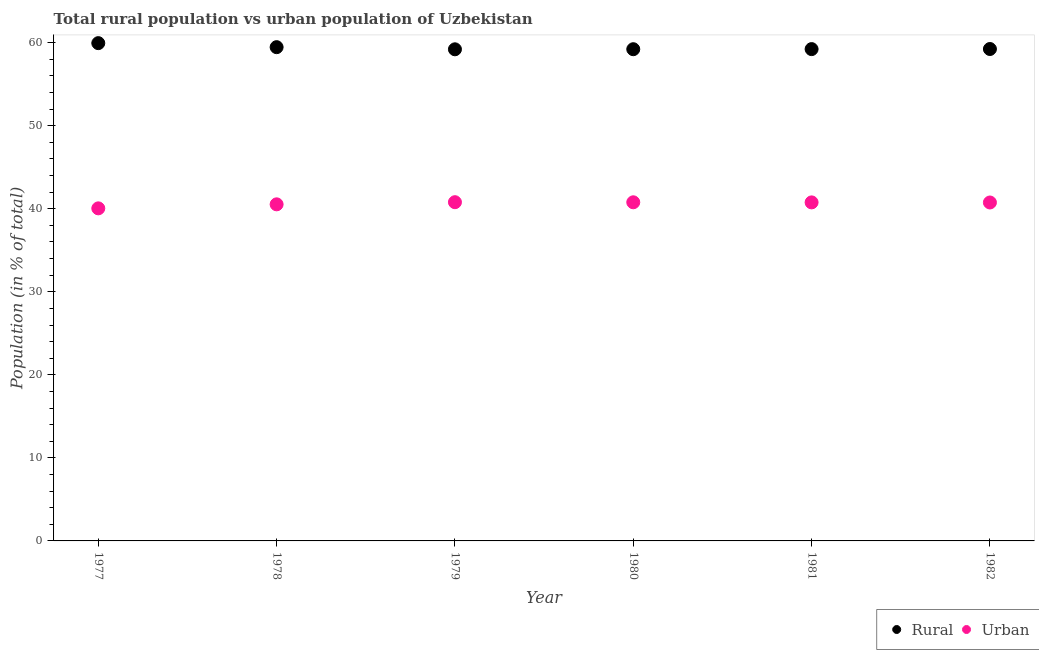What is the urban population in 1979?
Provide a short and direct response. 40.79. Across all years, what is the maximum urban population?
Your response must be concise. 40.79. Across all years, what is the minimum urban population?
Ensure brevity in your answer.  40.05. In which year was the urban population maximum?
Ensure brevity in your answer.  1979. What is the total urban population in the graph?
Keep it short and to the point. 243.69. What is the difference between the urban population in 1977 and that in 1981?
Offer a very short reply. -0.72. What is the difference between the urban population in 1982 and the rural population in 1979?
Your answer should be compact. -18.45. What is the average urban population per year?
Provide a short and direct response. 40.62. In the year 1980, what is the difference between the rural population and urban population?
Give a very brief answer. 18.44. What is the ratio of the urban population in 1979 to that in 1982?
Ensure brevity in your answer.  1. Is the rural population in 1979 less than that in 1981?
Provide a short and direct response. Yes. What is the difference between the highest and the second highest rural population?
Make the answer very short. 0.48. What is the difference between the highest and the lowest rural population?
Make the answer very short. 0.74. Is the sum of the rural population in 1979 and 1981 greater than the maximum urban population across all years?
Offer a very short reply. Yes. Does the urban population monotonically increase over the years?
Offer a terse response. No. Is the urban population strictly less than the rural population over the years?
Ensure brevity in your answer.  Yes. How many dotlines are there?
Your answer should be very brief. 2. How many years are there in the graph?
Offer a very short reply. 6. Are the values on the major ticks of Y-axis written in scientific E-notation?
Offer a very short reply. No. Does the graph contain any zero values?
Provide a short and direct response. No. How are the legend labels stacked?
Ensure brevity in your answer.  Horizontal. What is the title of the graph?
Make the answer very short. Total rural population vs urban population of Uzbekistan. What is the label or title of the Y-axis?
Provide a succinct answer. Population (in % of total). What is the Population (in % of total) in Rural in 1977?
Your response must be concise. 59.95. What is the Population (in % of total) of Urban in 1977?
Your answer should be compact. 40.05. What is the Population (in % of total) of Rural in 1978?
Make the answer very short. 59.46. What is the Population (in % of total) of Urban in 1978?
Give a very brief answer. 40.54. What is the Population (in % of total) in Rural in 1979?
Keep it short and to the point. 59.21. What is the Population (in % of total) of Urban in 1979?
Your response must be concise. 40.79. What is the Population (in % of total) in Rural in 1980?
Make the answer very short. 59.22. What is the Population (in % of total) of Urban in 1980?
Offer a very short reply. 40.78. What is the Population (in % of total) in Rural in 1981?
Provide a short and direct response. 59.23. What is the Population (in % of total) in Urban in 1981?
Keep it short and to the point. 40.77. What is the Population (in % of total) in Rural in 1982?
Provide a short and direct response. 59.24. What is the Population (in % of total) of Urban in 1982?
Keep it short and to the point. 40.76. Across all years, what is the maximum Population (in % of total) in Rural?
Keep it short and to the point. 59.95. Across all years, what is the maximum Population (in % of total) in Urban?
Provide a succinct answer. 40.79. Across all years, what is the minimum Population (in % of total) of Rural?
Offer a very short reply. 59.21. Across all years, what is the minimum Population (in % of total) in Urban?
Make the answer very short. 40.05. What is the total Population (in % of total) of Rural in the graph?
Ensure brevity in your answer.  356.31. What is the total Population (in % of total) of Urban in the graph?
Provide a succinct answer. 243.69. What is the difference between the Population (in % of total) in Rural in 1977 and that in 1978?
Give a very brief answer. 0.48. What is the difference between the Population (in % of total) in Urban in 1977 and that in 1978?
Your answer should be very brief. -0.48. What is the difference between the Population (in % of total) in Rural in 1977 and that in 1979?
Provide a short and direct response. 0.74. What is the difference between the Population (in % of total) in Urban in 1977 and that in 1979?
Your response must be concise. -0.74. What is the difference between the Population (in % of total) in Rural in 1977 and that in 1980?
Make the answer very short. 0.73. What is the difference between the Population (in % of total) of Urban in 1977 and that in 1980?
Your answer should be very brief. -0.73. What is the difference between the Population (in % of total) in Rural in 1977 and that in 1981?
Give a very brief answer. 0.72. What is the difference between the Population (in % of total) of Urban in 1977 and that in 1981?
Ensure brevity in your answer.  -0.72. What is the difference between the Population (in % of total) of Rural in 1977 and that in 1982?
Your answer should be compact. 0.71. What is the difference between the Population (in % of total) of Urban in 1977 and that in 1982?
Provide a succinct answer. -0.71. What is the difference between the Population (in % of total) of Rural in 1978 and that in 1979?
Provide a short and direct response. 0.26. What is the difference between the Population (in % of total) in Urban in 1978 and that in 1979?
Offer a very short reply. -0.26. What is the difference between the Population (in % of total) of Rural in 1978 and that in 1980?
Ensure brevity in your answer.  0.25. What is the difference between the Population (in % of total) of Urban in 1978 and that in 1980?
Provide a succinct answer. -0.25. What is the difference between the Population (in % of total) of Rural in 1978 and that in 1981?
Provide a short and direct response. 0.23. What is the difference between the Population (in % of total) in Urban in 1978 and that in 1981?
Provide a succinct answer. -0.23. What is the difference between the Population (in % of total) in Rural in 1978 and that in 1982?
Your answer should be very brief. 0.22. What is the difference between the Population (in % of total) in Urban in 1978 and that in 1982?
Keep it short and to the point. -0.22. What is the difference between the Population (in % of total) in Rural in 1979 and that in 1980?
Make the answer very short. -0.01. What is the difference between the Population (in % of total) of Urban in 1979 and that in 1980?
Offer a terse response. 0.01. What is the difference between the Population (in % of total) of Rural in 1979 and that in 1981?
Make the answer very short. -0.02. What is the difference between the Population (in % of total) in Urban in 1979 and that in 1981?
Provide a succinct answer. 0.02. What is the difference between the Population (in % of total) of Rural in 1979 and that in 1982?
Provide a succinct answer. -0.04. What is the difference between the Population (in % of total) in Urban in 1979 and that in 1982?
Ensure brevity in your answer.  0.04. What is the difference between the Population (in % of total) in Rural in 1980 and that in 1981?
Offer a terse response. -0.01. What is the difference between the Population (in % of total) in Urban in 1980 and that in 1981?
Provide a succinct answer. 0.01. What is the difference between the Population (in % of total) of Rural in 1980 and that in 1982?
Your response must be concise. -0.02. What is the difference between the Population (in % of total) of Urban in 1980 and that in 1982?
Your answer should be compact. 0.02. What is the difference between the Population (in % of total) of Rural in 1981 and that in 1982?
Your answer should be compact. -0.01. What is the difference between the Population (in % of total) in Urban in 1981 and that in 1982?
Your answer should be compact. 0.01. What is the difference between the Population (in % of total) in Rural in 1977 and the Population (in % of total) in Urban in 1978?
Provide a short and direct response. 19.41. What is the difference between the Population (in % of total) of Rural in 1977 and the Population (in % of total) of Urban in 1979?
Provide a short and direct response. 19.16. What is the difference between the Population (in % of total) in Rural in 1977 and the Population (in % of total) in Urban in 1980?
Your response must be concise. 19.17. What is the difference between the Population (in % of total) in Rural in 1977 and the Population (in % of total) in Urban in 1981?
Your answer should be very brief. 19.18. What is the difference between the Population (in % of total) of Rural in 1977 and the Population (in % of total) of Urban in 1982?
Your answer should be very brief. 19.19. What is the difference between the Population (in % of total) in Rural in 1978 and the Population (in % of total) in Urban in 1979?
Your answer should be very brief. 18.67. What is the difference between the Population (in % of total) in Rural in 1978 and the Population (in % of total) in Urban in 1980?
Your answer should be compact. 18.68. What is the difference between the Population (in % of total) in Rural in 1978 and the Population (in % of total) in Urban in 1981?
Your answer should be very brief. 18.69. What is the difference between the Population (in % of total) in Rural in 1978 and the Population (in % of total) in Urban in 1982?
Ensure brevity in your answer.  18.71. What is the difference between the Population (in % of total) of Rural in 1979 and the Population (in % of total) of Urban in 1980?
Make the answer very short. 18.42. What is the difference between the Population (in % of total) in Rural in 1979 and the Population (in % of total) in Urban in 1981?
Ensure brevity in your answer.  18.44. What is the difference between the Population (in % of total) in Rural in 1979 and the Population (in % of total) in Urban in 1982?
Your answer should be very brief. 18.45. What is the difference between the Population (in % of total) in Rural in 1980 and the Population (in % of total) in Urban in 1981?
Offer a terse response. 18.45. What is the difference between the Population (in % of total) of Rural in 1980 and the Population (in % of total) of Urban in 1982?
Your response must be concise. 18.46. What is the difference between the Population (in % of total) of Rural in 1981 and the Population (in % of total) of Urban in 1982?
Your response must be concise. 18.47. What is the average Population (in % of total) in Rural per year?
Offer a terse response. 59.38. What is the average Population (in % of total) of Urban per year?
Your answer should be compact. 40.62. In the year 1977, what is the difference between the Population (in % of total) of Rural and Population (in % of total) of Urban?
Your answer should be compact. 19.9. In the year 1978, what is the difference between the Population (in % of total) of Rural and Population (in % of total) of Urban?
Your answer should be very brief. 18.93. In the year 1979, what is the difference between the Population (in % of total) in Rural and Population (in % of total) in Urban?
Give a very brief answer. 18.41. In the year 1980, what is the difference between the Population (in % of total) in Rural and Population (in % of total) in Urban?
Offer a very short reply. 18.44. In the year 1981, what is the difference between the Population (in % of total) in Rural and Population (in % of total) in Urban?
Your answer should be compact. 18.46. In the year 1982, what is the difference between the Population (in % of total) of Rural and Population (in % of total) of Urban?
Offer a very short reply. 18.48. What is the ratio of the Population (in % of total) in Rural in 1977 to that in 1978?
Your response must be concise. 1.01. What is the ratio of the Population (in % of total) of Rural in 1977 to that in 1979?
Provide a succinct answer. 1.01. What is the ratio of the Population (in % of total) of Urban in 1977 to that in 1979?
Give a very brief answer. 0.98. What is the ratio of the Population (in % of total) in Rural in 1977 to that in 1980?
Offer a terse response. 1.01. What is the ratio of the Population (in % of total) of Urban in 1977 to that in 1980?
Your response must be concise. 0.98. What is the ratio of the Population (in % of total) of Rural in 1977 to that in 1981?
Provide a short and direct response. 1.01. What is the ratio of the Population (in % of total) in Urban in 1977 to that in 1981?
Provide a short and direct response. 0.98. What is the ratio of the Population (in % of total) of Rural in 1977 to that in 1982?
Offer a terse response. 1.01. What is the ratio of the Population (in % of total) in Urban in 1977 to that in 1982?
Your answer should be compact. 0.98. What is the ratio of the Population (in % of total) in Rural in 1978 to that in 1979?
Provide a succinct answer. 1. What is the ratio of the Population (in % of total) of Rural in 1978 to that in 1981?
Your response must be concise. 1. What is the ratio of the Population (in % of total) in Urban in 1978 to that in 1982?
Give a very brief answer. 0.99. What is the ratio of the Population (in % of total) of Rural in 1979 to that in 1980?
Your response must be concise. 1. What is the ratio of the Population (in % of total) of Rural in 1979 to that in 1982?
Your answer should be compact. 1. What is the ratio of the Population (in % of total) of Urban in 1980 to that in 1981?
Ensure brevity in your answer.  1. What is the ratio of the Population (in % of total) in Urban in 1980 to that in 1982?
Offer a terse response. 1. What is the ratio of the Population (in % of total) of Rural in 1981 to that in 1982?
Make the answer very short. 1. What is the ratio of the Population (in % of total) in Urban in 1981 to that in 1982?
Keep it short and to the point. 1. What is the difference between the highest and the second highest Population (in % of total) of Rural?
Your answer should be compact. 0.48. What is the difference between the highest and the second highest Population (in % of total) in Urban?
Offer a very short reply. 0.01. What is the difference between the highest and the lowest Population (in % of total) in Rural?
Offer a very short reply. 0.74. What is the difference between the highest and the lowest Population (in % of total) of Urban?
Offer a very short reply. 0.74. 